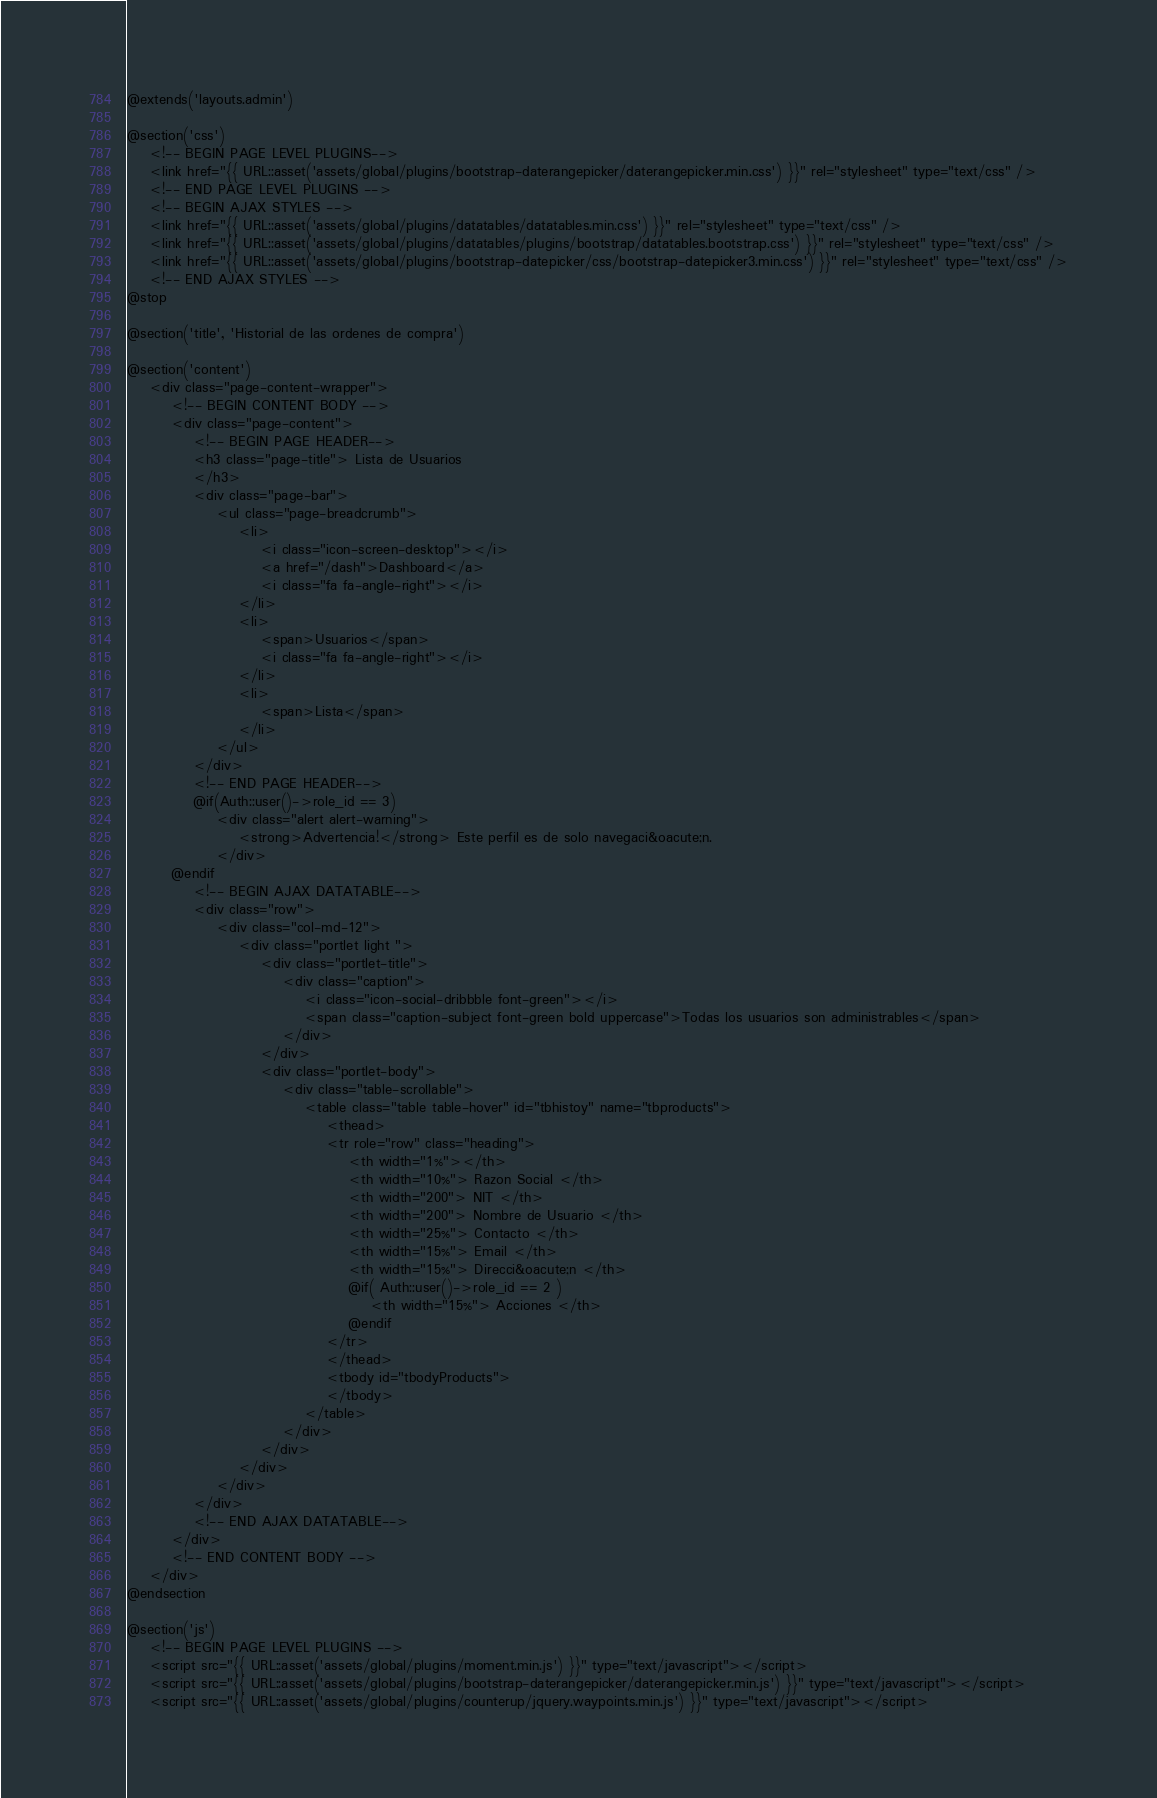<code> <loc_0><loc_0><loc_500><loc_500><_PHP_>@extends('layouts.admin')

@section('css')
    <!-- BEGIN PAGE LEVEL PLUGINS-->
    <link href="{{ URL::asset('assets/global/plugins/bootstrap-daterangepicker/daterangepicker.min.css') }}" rel="stylesheet" type="text/css" />
    <!-- END PAGE LEVEL PLUGINS -->
    <!-- BEGIN AJAX STYLES -->
    <link href="{{ URL::asset('assets/global/plugins/datatables/datatables.min.css') }}" rel="stylesheet" type="text/css" />
    <link href="{{ URL::asset('assets/global/plugins/datatables/plugins/bootstrap/datatables.bootstrap.css') }}" rel="stylesheet" type="text/css" />
    <link href="{{ URL::asset('assets/global/plugins/bootstrap-datepicker/css/bootstrap-datepicker3.min.css') }}" rel="stylesheet" type="text/css" />
    <!-- END AJAX STYLES -->
@stop

@section('title', 'Historial de las ordenes de compra')

@section('content')
    <div class="page-content-wrapper">
        <!-- BEGIN CONTENT BODY -->
        <div class="page-content">
            <!-- BEGIN PAGE HEADER-->
            <h3 class="page-title"> Lista de Usuarios
            </h3>
            <div class="page-bar">
                <ul class="page-breadcrumb">
                    <li>
                        <i class="icon-screen-desktop"></i>
                        <a href="/dash">Dashboard</a>
                        <i class="fa fa-angle-right"></i>
                    </li>
                    <li>
                        <span>Usuarios</span>
                        <i class="fa fa-angle-right"></i>
                    </li>
                    <li>
                        <span>Lista</span>
                    </li>
                </ul>
            </div>
            <!-- END PAGE HEADER-->
            @if(Auth::user()->role_id == 3)
                <div class="alert alert-warning">
                    <strong>Advertencia!</strong> Este perfil es de solo navegaci&oacute;n.
                </div>
        @endif
            <!-- BEGIN AJAX DATATABLE-->
            <div class="row">
                <div class="col-md-12">
                    <div class="portlet light ">
                        <div class="portlet-title">
                            <div class="caption">
                                <i class="icon-social-dribbble font-green"></i>
                                <span class="caption-subject font-green bold uppercase">Todas los usuarios son administrables</span>
                            </div>
                        </div>
                        <div class="portlet-body">
                            <div class="table-scrollable">
                                <table class="table table-hover" id="tbhistoy" name="tbproducts">
                                    <thead>
                                    <tr role="row" class="heading">
                                        <th width="1%"></th>
                                        <th width="10%"> Razon Social </th>
                                        <th width="200"> NIT </th>
                                        <th width="200"> Nombre de Usuario </th>
                                        <th width="25%"> Contacto </th>
                                        <th width="15%"> Email </th>
                                        <th width="15%"> Direcci&oacute;n </th>
                                        @if( Auth::user()->role_id == 2 )
                                            <th width="15%"> Acciones </th>
                                        @endif
                                    </tr>
                                    </thead>
                                    <tbody id="tbodyProducts">
                                    </tbody>
                                </table>
                            </div>
                        </div>
                    </div>
                </div>
            </div>
            <!-- END AJAX DATATABLE-->
        </div>
        <!-- END CONTENT BODY -->
    </div>
@endsection

@section('js')
    <!-- BEGIN PAGE LEVEL PLUGINS -->
    <script src="{{ URL::asset('assets/global/plugins/moment.min.js') }}" type="text/javascript"></script>
    <script src="{{ URL::asset('assets/global/plugins/bootstrap-daterangepicker/daterangepicker.min.js') }}" type="text/javascript"></script>
    <script src="{{ URL::asset('assets/global/plugins/counterup/jquery.waypoints.min.js') }}" type="text/javascript"></script></code> 